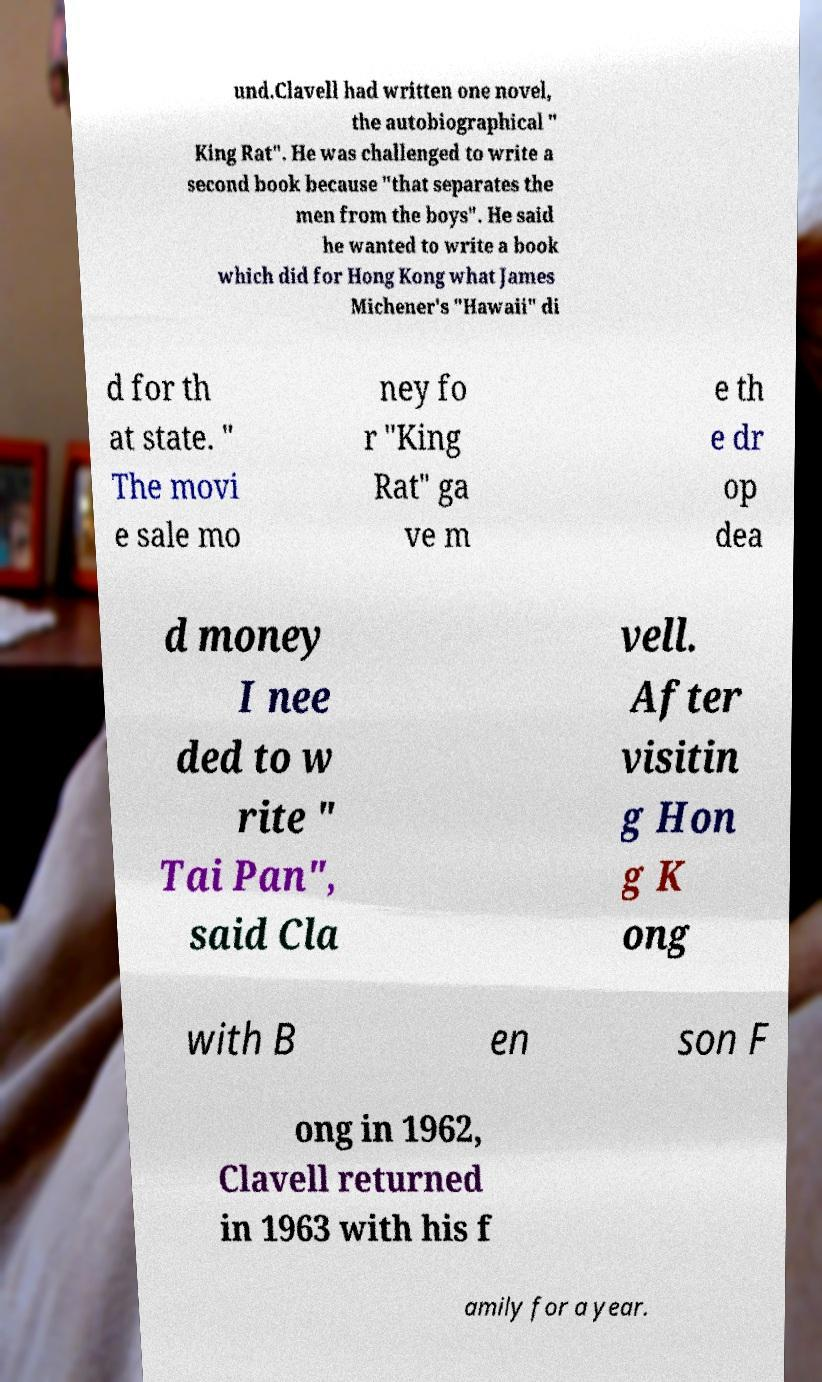Can you read and provide the text displayed in the image?This photo seems to have some interesting text. Can you extract and type it out for me? und.Clavell had written one novel, the autobiographical " King Rat". He was challenged to write a second book because "that separates the men from the boys". He said he wanted to write a book which did for Hong Kong what James Michener's "Hawaii" di d for th at state. " The movi e sale mo ney fo r "King Rat" ga ve m e th e dr op dea d money I nee ded to w rite " Tai Pan", said Cla vell. After visitin g Hon g K ong with B en son F ong in 1962, Clavell returned in 1963 with his f amily for a year. 